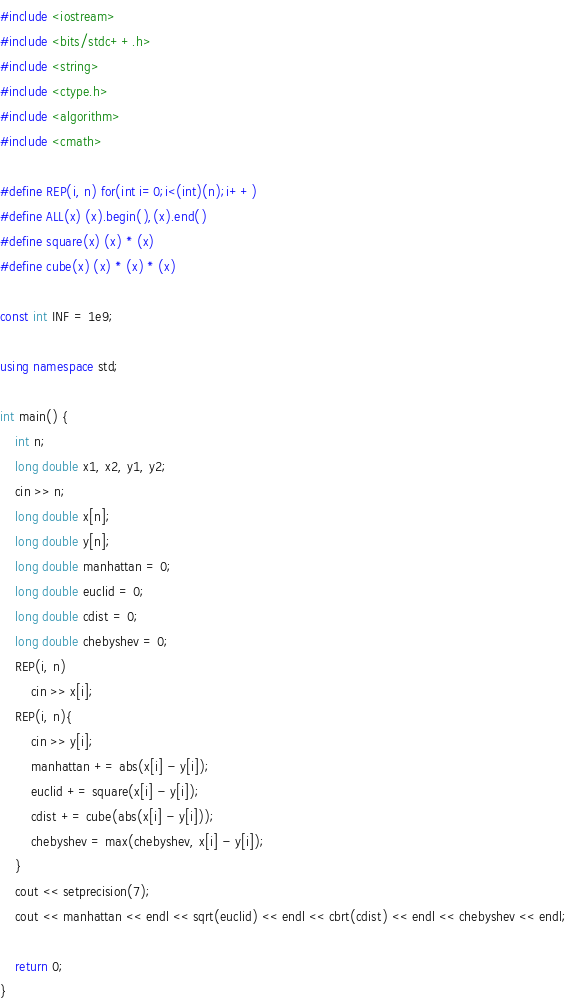Convert code to text. <code><loc_0><loc_0><loc_500><loc_500><_C++_>#include <iostream>
#include <bits/stdc++.h>
#include <string>
#include <ctype.h>
#include <algorithm>
#include <cmath>

#define REP(i, n) for(int i=0;i<(int)(n);i++)
#define ALL(x) (x).begin(),(x).end()
#define square(x) (x) * (x)
#define cube(x) (x) * (x) * (x)

const int INF = 1e9;

using namespace std;

int main() {
    int n;
    long double x1, x2, y1, y2;
    cin >> n;
    long double x[n];
    long double y[n];
    long double manhattan = 0;
    long double euclid = 0;
    long double cdist = 0;
    long double chebyshev = 0;
    REP(i, n)
        cin >> x[i];
    REP(i, n){
        cin >> y[i];
        manhattan += abs(x[i] - y[i]);
        euclid += square(x[i] - y[i]);
        cdist += cube(abs(x[i] - y[i]));
        chebyshev = max(chebyshev, x[i] - y[i]);
    }
    cout << setprecision(7);
    cout << manhattan << endl << sqrt(euclid) << endl << cbrt(cdist) << endl << chebyshev << endl;

    return 0;
}</code> 